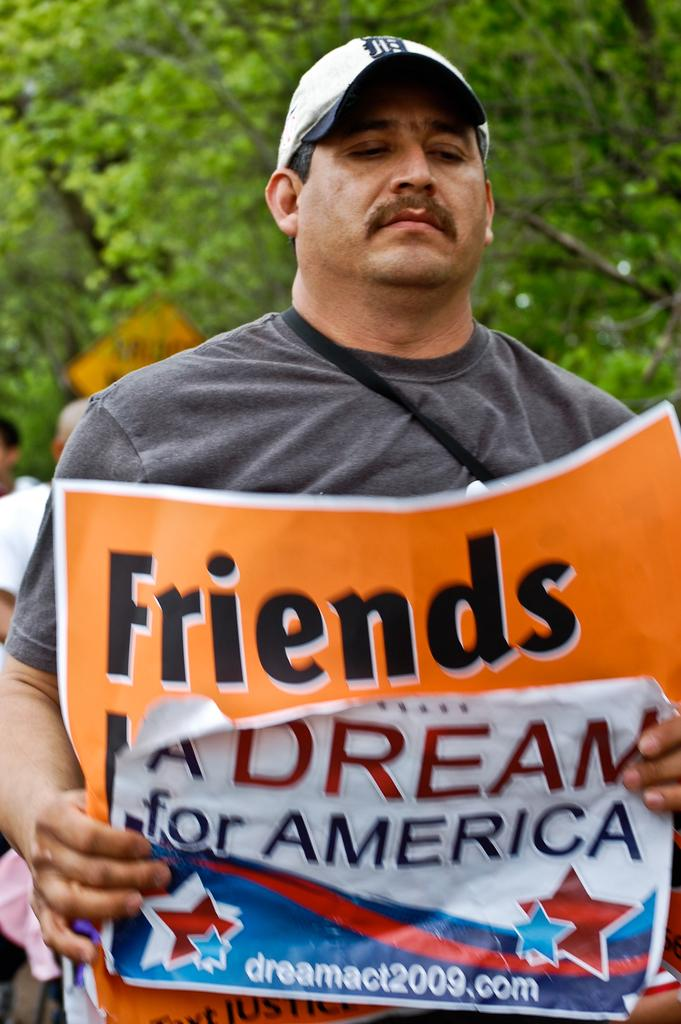Provide a one-sentence caption for the provided image. A man holds an orange banner that says Friends on top. 